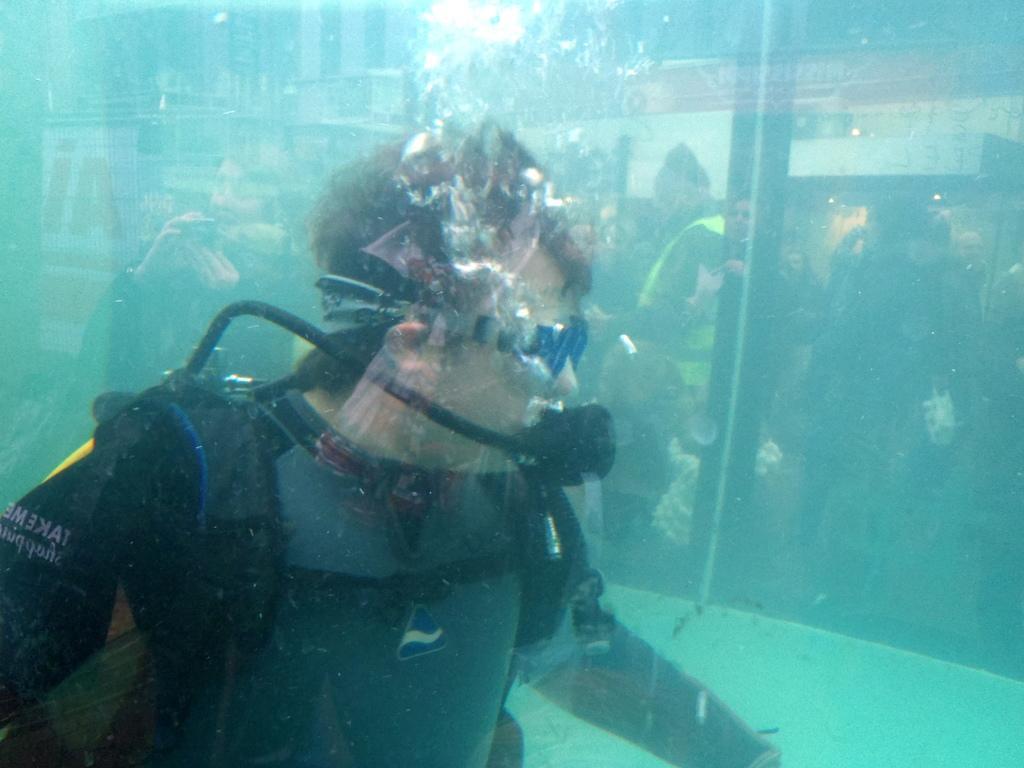Please provide a concise description of this image. This image consists of a man swimming in the tank. He is wearing an oxygen mask. And there is water in the tank. In the background, there are many people and a building along with the tree. At the top, there is a sky. 